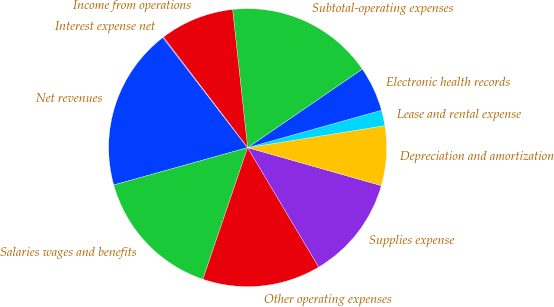<chart> <loc_0><loc_0><loc_500><loc_500><pie_chart><fcel>Net revenues<fcel>Salaries wages and benefits<fcel>Other operating expenses<fcel>Supplies expense<fcel>Depreciation and amortization<fcel>Lease and rental expense<fcel>Electronic health records<fcel>Subtotal-operating expenses<fcel>Income from operations<fcel>Interest expense net<nl><fcel>18.88%<fcel>15.46%<fcel>13.76%<fcel>12.05%<fcel>6.93%<fcel>1.81%<fcel>5.22%<fcel>17.17%<fcel>8.63%<fcel>0.1%<nl></chart> 